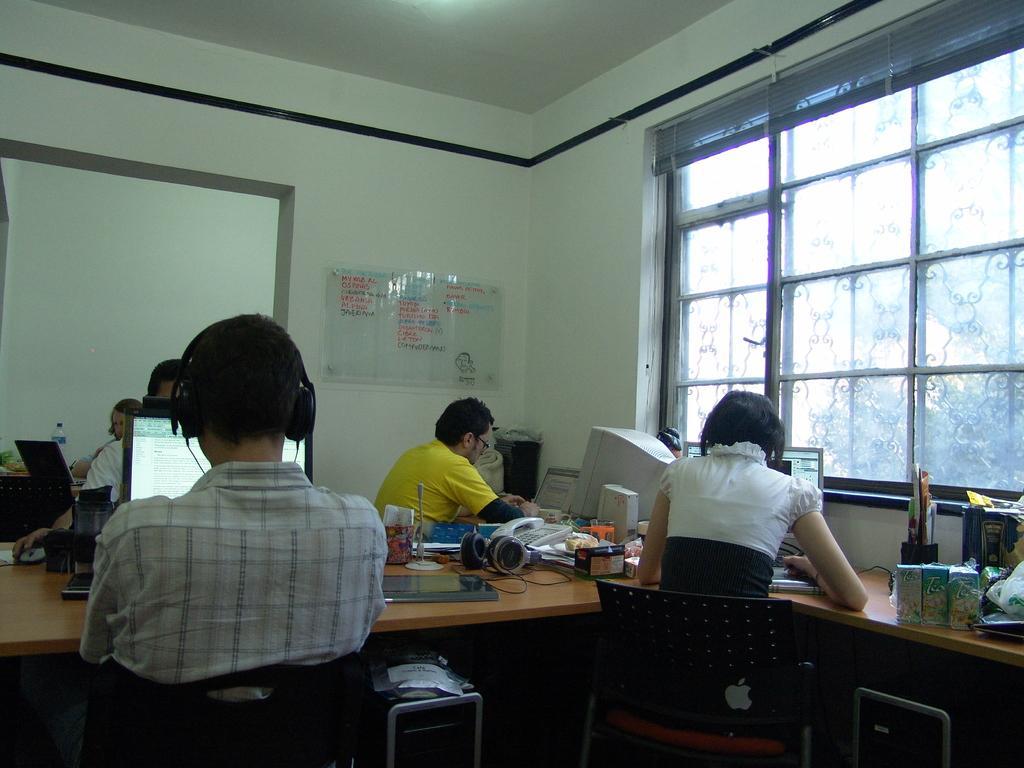How would you summarize this image in a sentence or two? In this image I can see few people are sitting on chairs. I can also see laptops, computers and few more stuffs on these tables. 